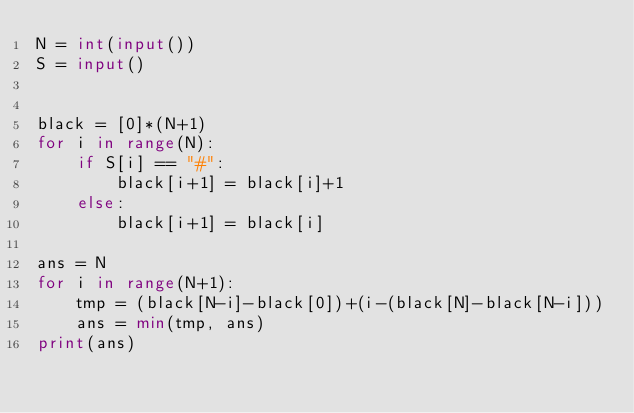Convert code to text. <code><loc_0><loc_0><loc_500><loc_500><_Python_>N = int(input())
S = input()


black = [0]*(N+1)
for i in range(N):
    if S[i] == "#":
        black[i+1] = black[i]+1
    else:
        black[i+1] = black[i]

ans = N
for i in range(N+1):
    tmp = (black[N-i]-black[0])+(i-(black[N]-black[N-i]))
    ans = min(tmp, ans)
print(ans)
</code> 